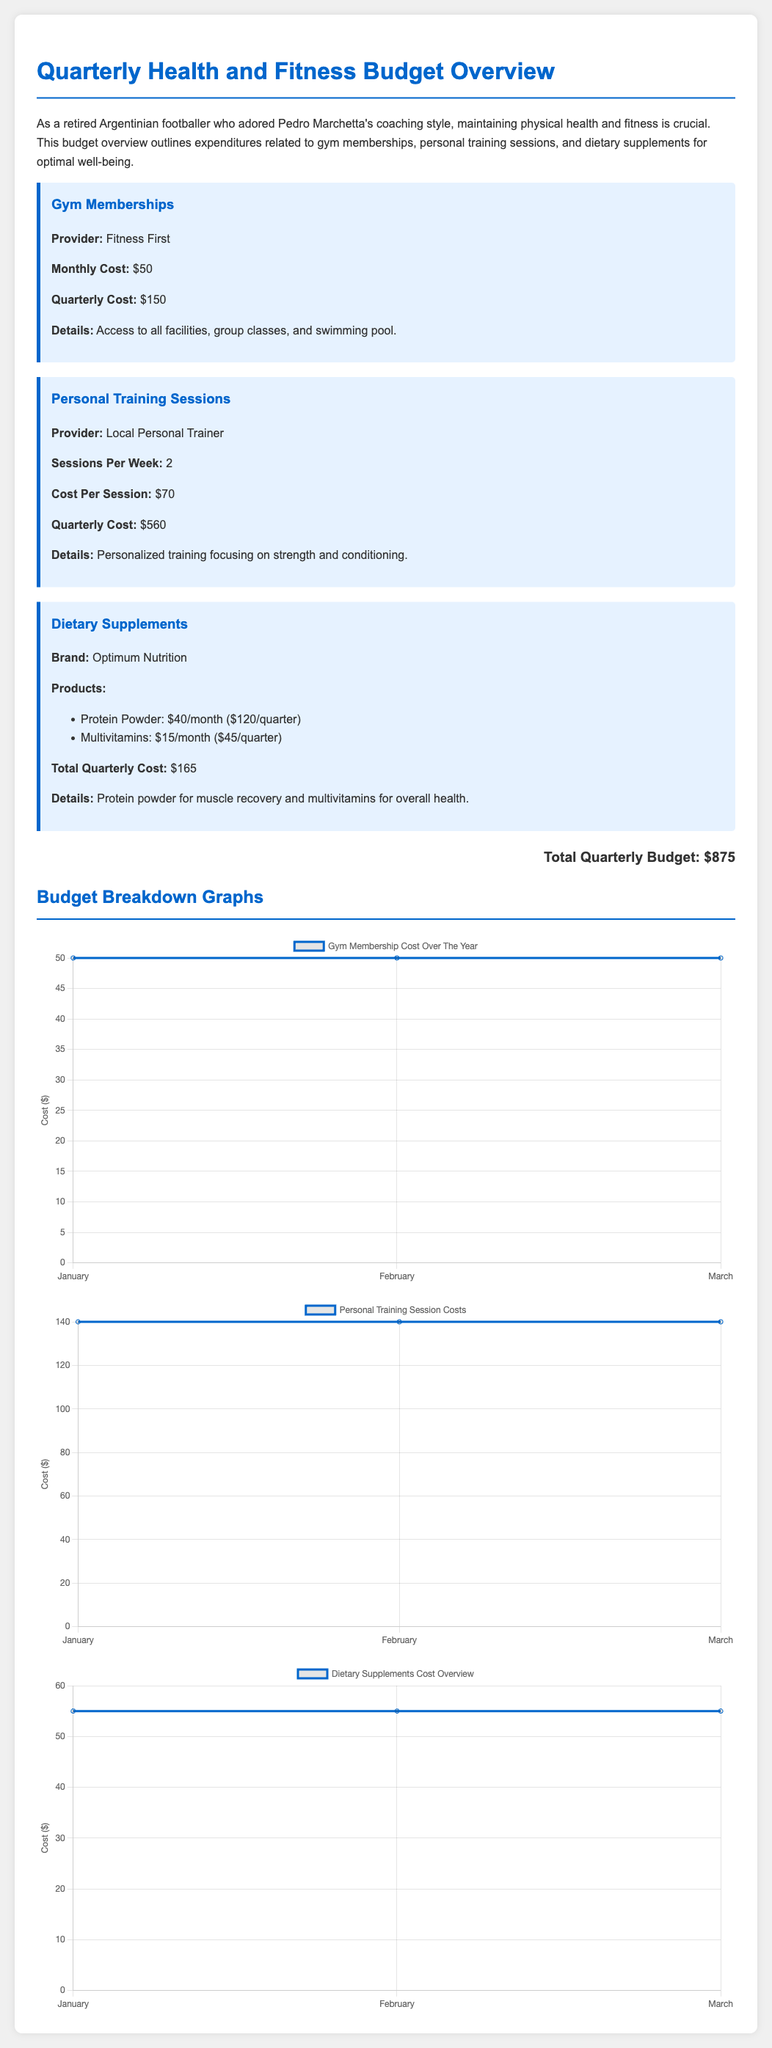What is the total cost for gym memberships this quarter? The total cost for gym memberships is provided in the document as the quarterly cost of $150.
Answer: $150 How much does one personal training session cost? The document states that the cost per personal training session is $70.
Answer: $70 What are the monthly costs for dietary supplements? The document lists the costs of dietary supplements per month, which are $40 for protein powder and $15 for multivitamins.
Answer: $40, $15 What is the total quarterly expenditure on dietary supplements? The total quarterly cost for dietary supplements is specified as $165.
Answer: $165 How many personal training sessions are included per week? The document indicates that there are 2 personal training sessions per week.
Answer: 2 What is the total quarterly budget overview? The document summarizes the total quarterly budget as $875.
Answer: $875 Which gym provider is mentioned in the budget? The budget overview lists "Fitness First" as the gym provider.
Answer: Fitness First What details are included for the dietary supplements? The document specifies protein powder for muscle recovery and multivitamins for overall health as details for dietary supplements.
Answer: Protein powder, multivitamins What type of graph is used to represent the gym membership cost? The document uses a line graph to represent the gym membership cost over the year.
Answer: Line graph 